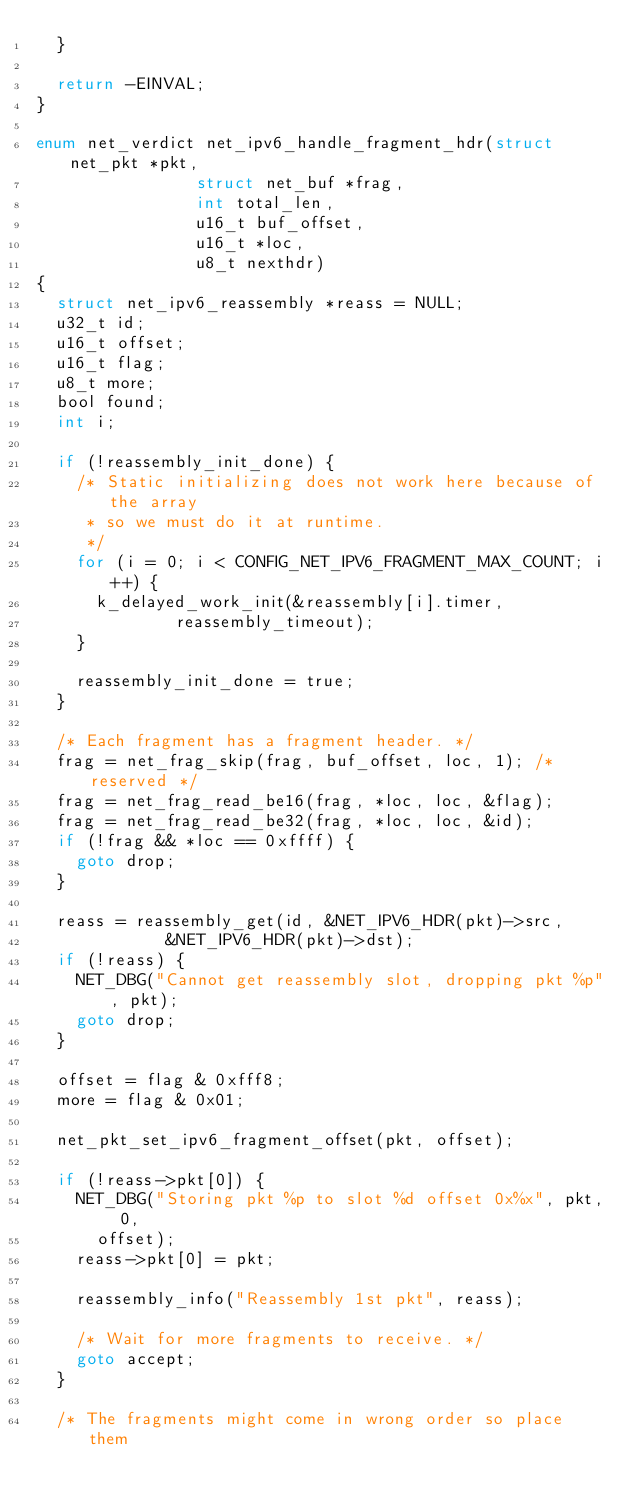<code> <loc_0><loc_0><loc_500><loc_500><_C_>	}

	return -EINVAL;
}

enum net_verdict net_ipv6_handle_fragment_hdr(struct net_pkt *pkt,
					      struct net_buf *frag,
					      int total_len,
					      u16_t buf_offset,
					      u16_t *loc,
					      u8_t nexthdr)
{
	struct net_ipv6_reassembly *reass = NULL;
	u32_t id;
	u16_t offset;
	u16_t flag;
	u8_t more;
	bool found;
	int i;

	if (!reassembly_init_done) {
		/* Static initializing does not work here because of the array
		 * so we must do it at runtime.
		 */
		for (i = 0; i < CONFIG_NET_IPV6_FRAGMENT_MAX_COUNT; i++) {
			k_delayed_work_init(&reassembly[i].timer,
					    reassembly_timeout);
		}

		reassembly_init_done = true;
	}

	/* Each fragment has a fragment header. */
	frag = net_frag_skip(frag, buf_offset, loc, 1); /* reserved */
	frag = net_frag_read_be16(frag, *loc, loc, &flag);
	frag = net_frag_read_be32(frag, *loc, loc, &id);
	if (!frag && *loc == 0xffff) {
		goto drop;
	}

	reass = reassembly_get(id, &NET_IPV6_HDR(pkt)->src,
			       &NET_IPV6_HDR(pkt)->dst);
	if (!reass) {
		NET_DBG("Cannot get reassembly slot, dropping pkt %p", pkt);
		goto drop;
	}

	offset = flag & 0xfff8;
	more = flag & 0x01;

	net_pkt_set_ipv6_fragment_offset(pkt, offset);

	if (!reass->pkt[0]) {
		NET_DBG("Storing pkt %p to slot %d offset 0x%x", pkt, 0,
			offset);
		reass->pkt[0] = pkt;

		reassembly_info("Reassembly 1st pkt", reass);

		/* Wait for more fragments to receive. */
		goto accept;
	}

	/* The fragments might come in wrong order so place them</code> 